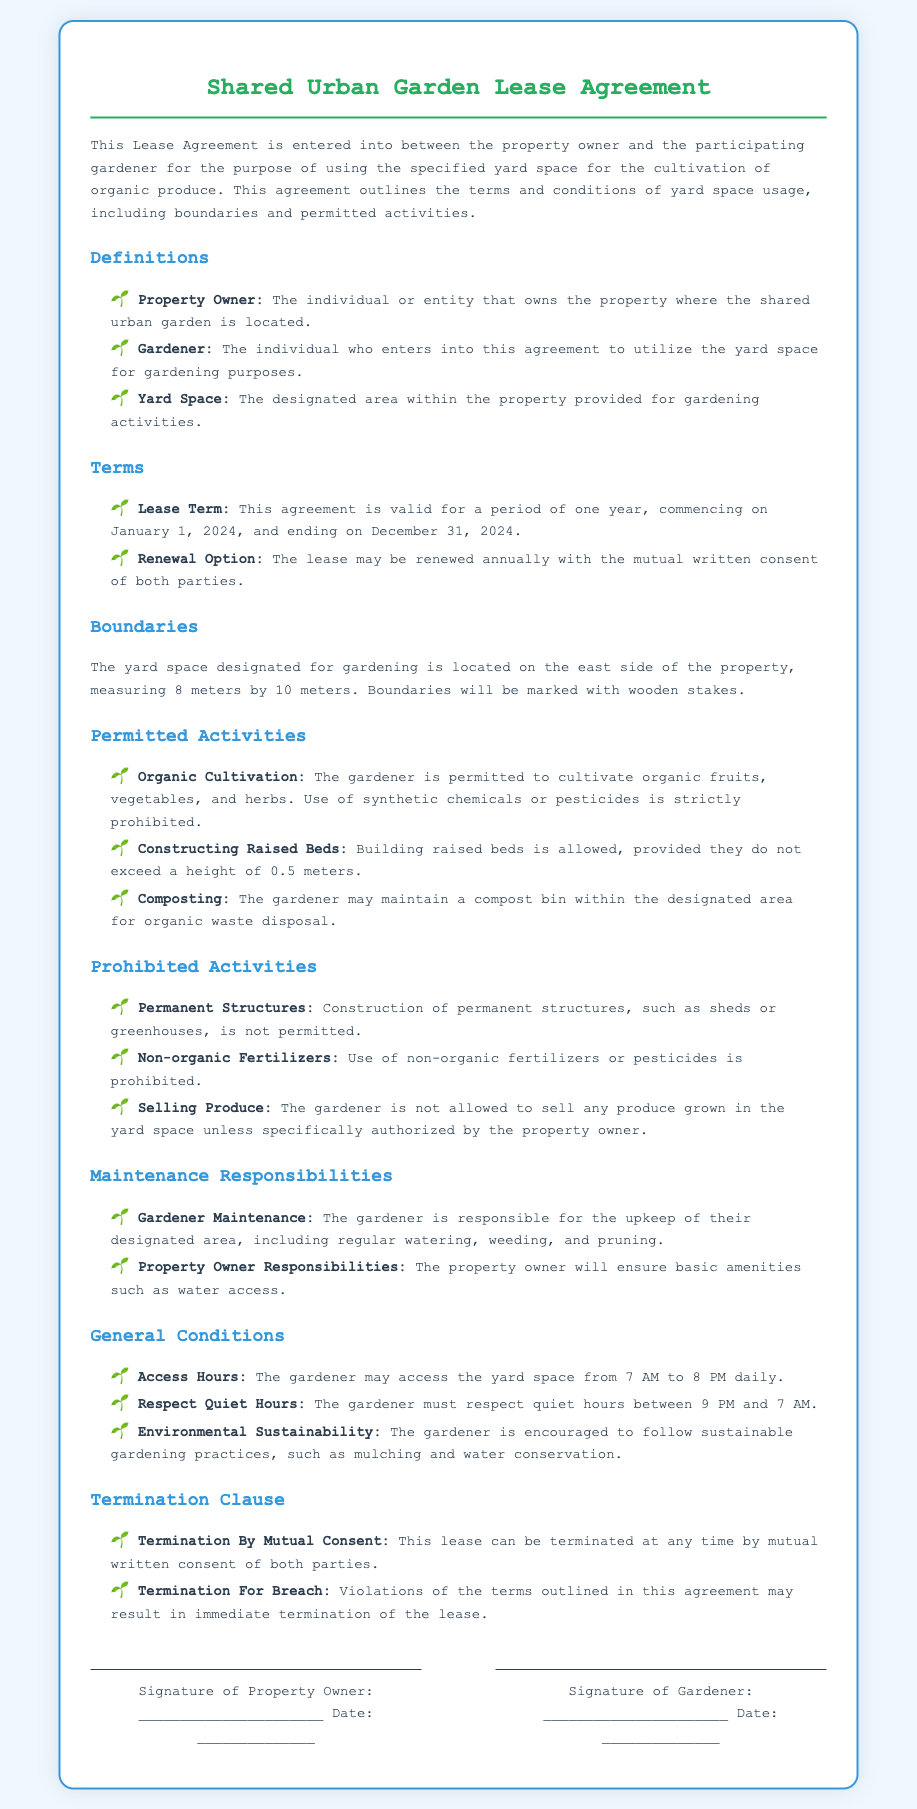What is the lease term duration? The lease term duration is specified in the document as one year, from January 1, 2024, to December 31, 2024.
Answer: one year Where is the yard space located? The document specifies that the yard space is located on the east side of the property.
Answer: east side What activities are gardeners strictly prohibited from doing? The document lists several prohibited activities, including using non-organic fertilizers and selling produce grown in the yard space without authorization.
Answer: using non-organic fertilizers What is the height limit for constructed raised beds? The document states that raised beds must not exceed a height of 0.5 meters.
Answer: 0.5 meters When can the gardener access the yard space? The access hours for the gardener are outlined in the document as being from 7 AM to 8 PM daily.
Answer: 7 AM to 8 PM What must gardeners respect between 9 PM and 7 AM? The document outlines that gardeners must respect quiet hours between these times.
Answer: quiet hours What happens if there is a violation of the terms? The document specifies that violations may result in immediate termination of the lease.
Answer: immediate termination Who is responsible for maintenance of the designated area? The gardener is responsible for the upkeep of their designated area as per the document's maintenance responsibilities section.
Answer: gardener What is the renewal option stated in the agreement? According to the document, the lease may be renewed annually with mutual written consent from both parties.
Answer: mutual written consent 